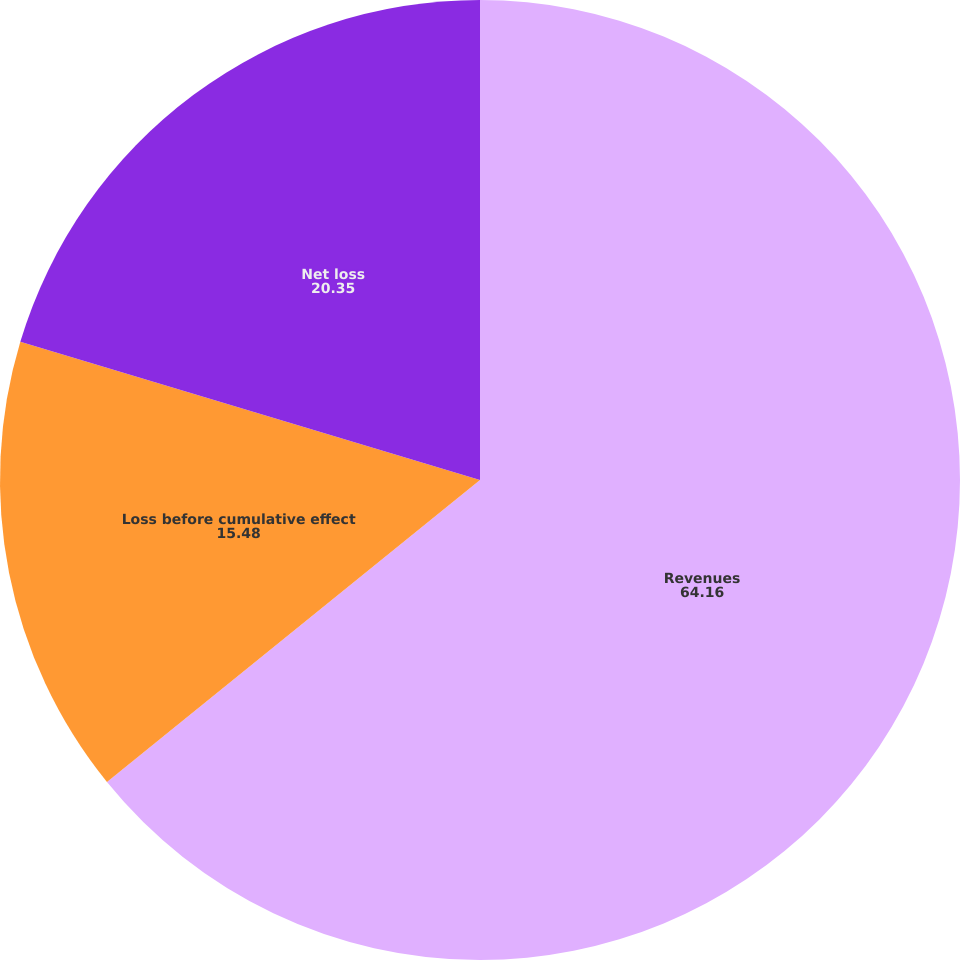Convert chart. <chart><loc_0><loc_0><loc_500><loc_500><pie_chart><fcel>Revenues<fcel>Loss before cumulative effect<fcel>Net loss<nl><fcel>64.16%<fcel>15.48%<fcel>20.35%<nl></chart> 